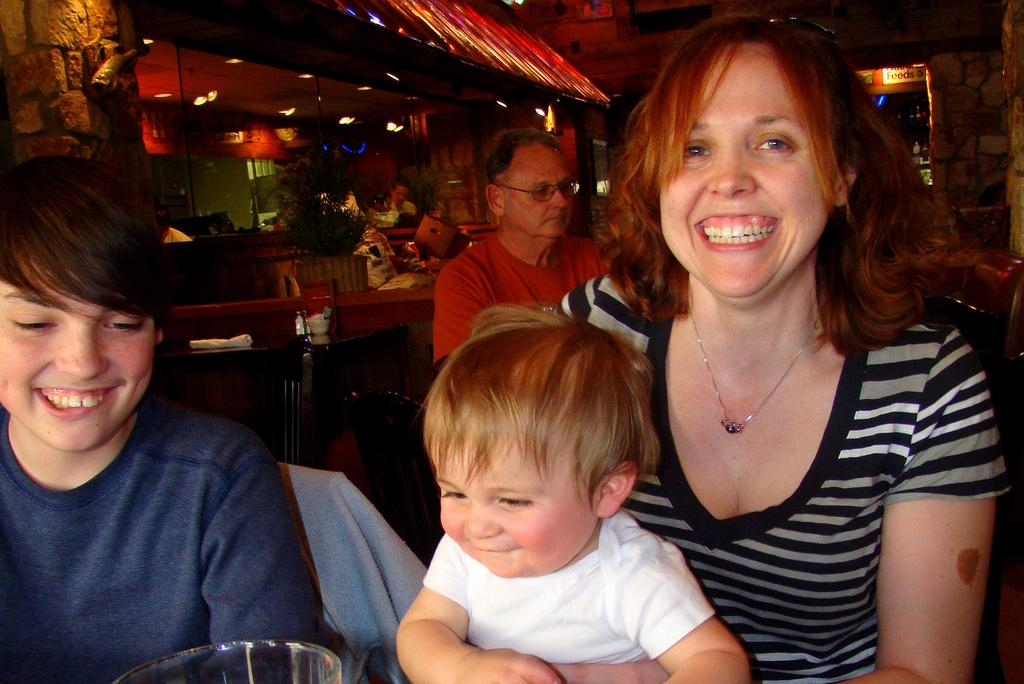How many people are in the image? There are few persons in the image. What is the woman in the image doing? A woman is holding a kid in the front of the image. What can be seen in the background of the image? There is a wall and a roof in the background of the image. What type of plant is present in the image? There is a potted plant in the image. What is the source of illumination in the image? There is a light in the image. What type of news is being discussed by the persons in the image? There is no indication of any news being discussed in the image. The focus is on the woman holding a kid and the background elements. 